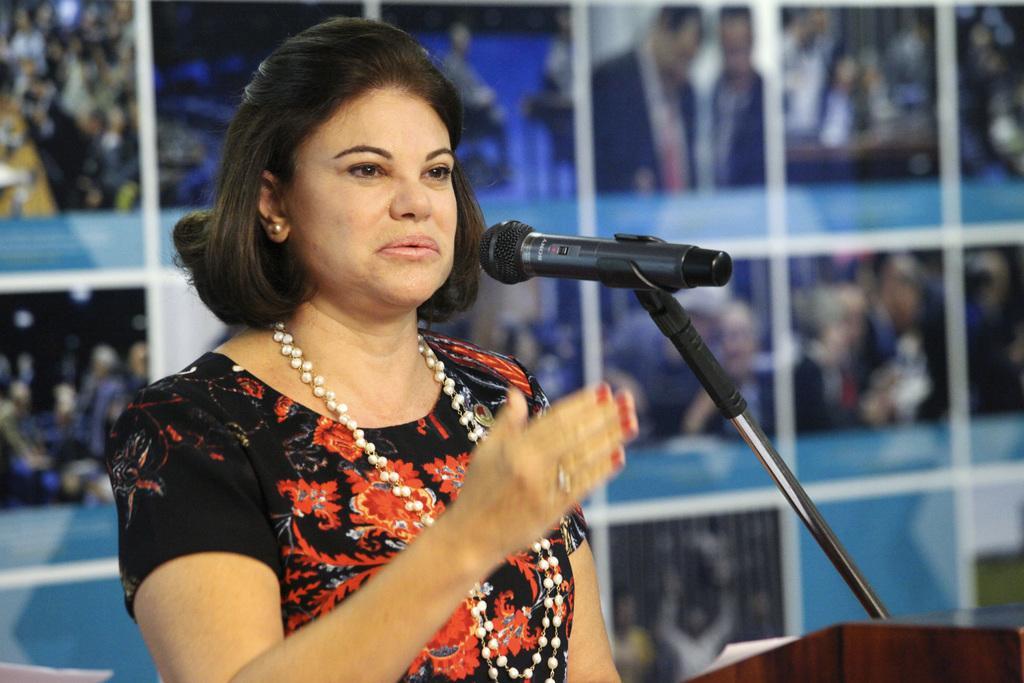How would you summarize this image in a sentence or two? In the background we can see the photo frames. We can see a woman wearing a pearl chain, standing near to a podium and talking. In this picture we can see a mike, stand and a paper. 